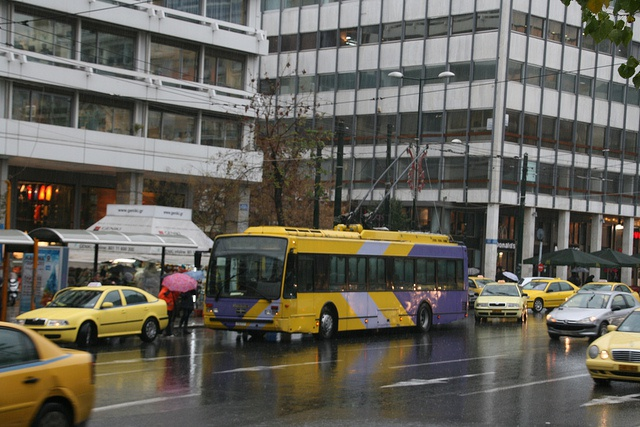Describe the objects in this image and their specific colors. I can see bus in black, gray, olive, and darkgray tones, car in black, olive, and maroon tones, car in black, khaki, tan, and gray tones, car in black, darkgray, lightgray, and gray tones, and car in black, khaki, olive, and darkgray tones in this image. 